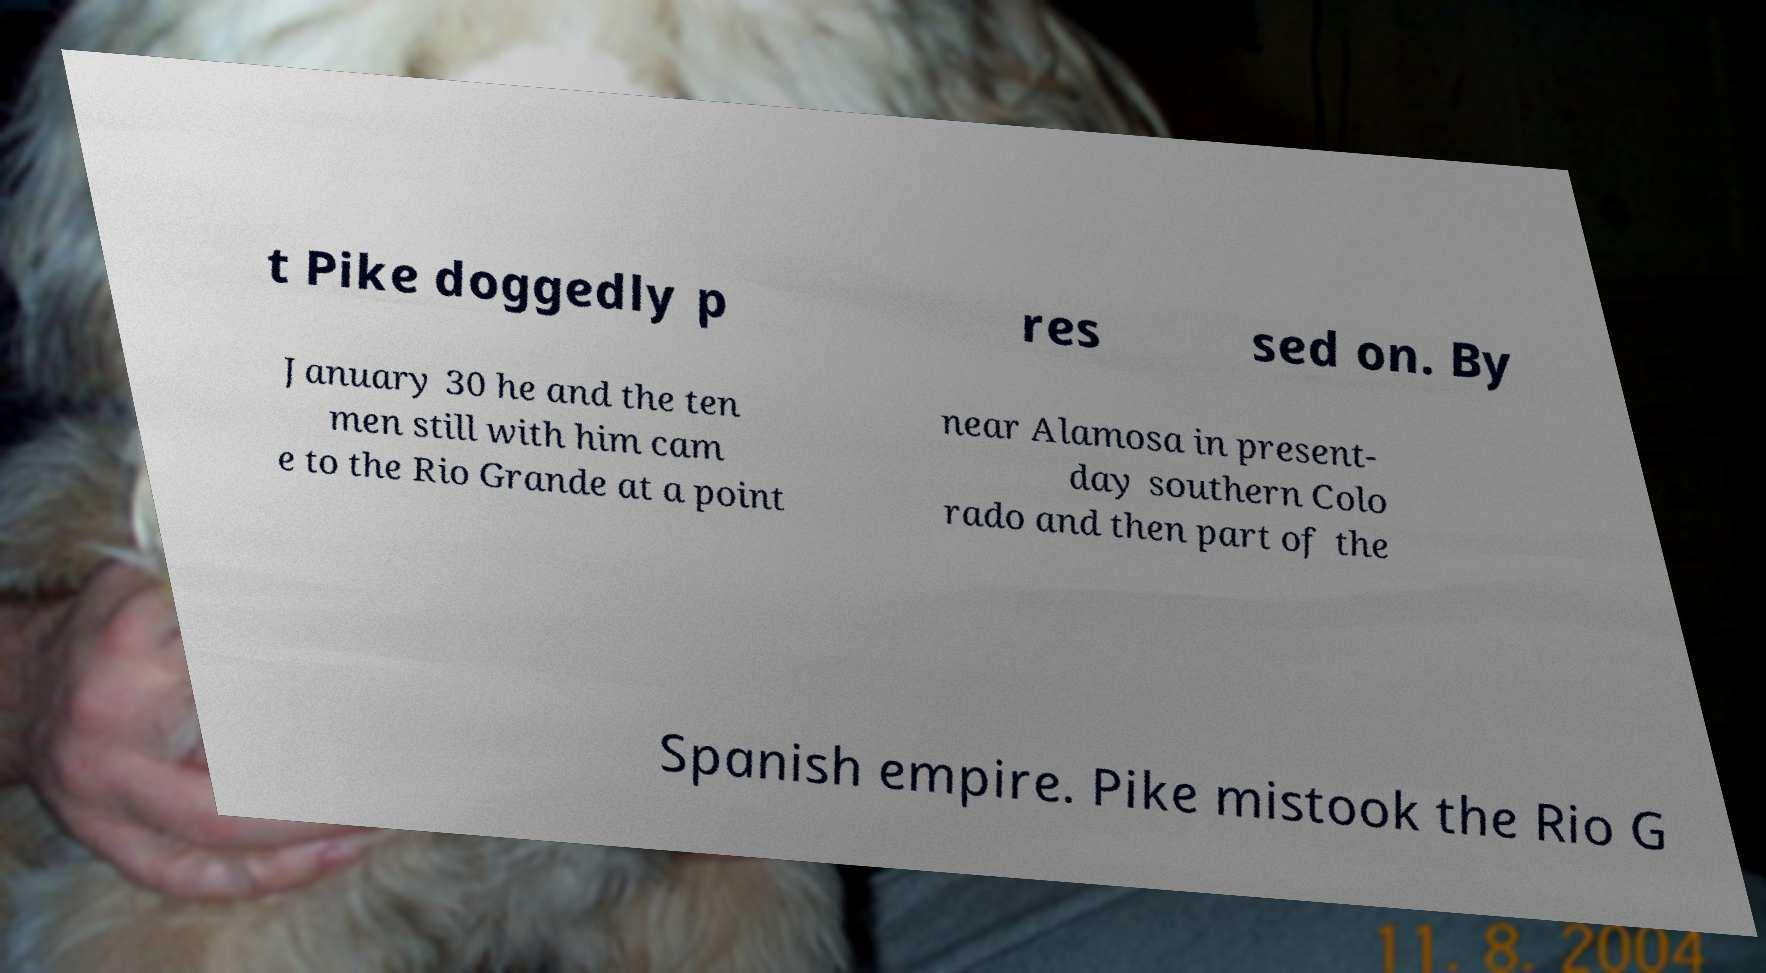What messages or text are displayed in this image? I need them in a readable, typed format. t Pike doggedly p res sed on. By January 30 he and the ten men still with him cam e to the Rio Grande at a point near Alamosa in present- day southern Colo rado and then part of the Spanish empire. Pike mistook the Rio G 